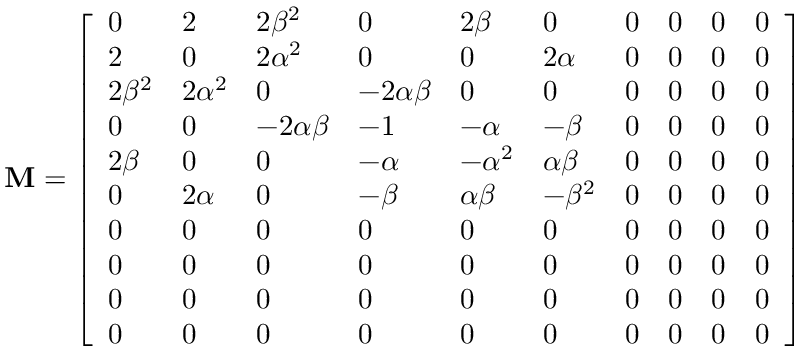<formula> <loc_0><loc_0><loc_500><loc_500>M = \left [ \begin{array} { l l l l l l l l l l } { 0 } & { 2 } & { 2 \beta ^ { 2 } } & { 0 } & { 2 \beta } & { 0 } & { 0 } & { 0 } & { 0 } & { 0 } \\ { 2 } & { 0 } & { 2 \alpha ^ { 2 } } & { 0 } & { 0 } & { 2 \alpha } & { 0 } & { 0 } & { 0 } & { 0 } \\ { 2 \beta ^ { 2 } } & { 2 \alpha ^ { 2 } } & { 0 } & { - 2 \alpha \beta } & { 0 } & { 0 } & { 0 } & { 0 } & { 0 } & { 0 } \\ { 0 } & { 0 } & { - 2 \alpha \beta } & { - 1 } & { - \alpha } & { - \beta } & { 0 } & { 0 } & { 0 } & { 0 } \\ { 2 \beta } & { 0 } & { 0 } & { - \alpha } & { - \alpha ^ { 2 } } & { \alpha \beta } & { 0 } & { 0 } & { 0 } & { 0 } \\ { 0 } & { 2 \alpha } & { 0 } & { - \beta } & { \alpha \beta } & { - \beta ^ { 2 } } & { 0 } & { 0 } & { 0 } & { 0 } \\ { 0 } & { 0 } & { 0 } & { 0 } & { 0 } & { 0 } & { 0 } & { 0 } & { 0 } & { 0 } \\ { 0 } & { 0 } & { 0 } & { 0 } & { 0 } & { 0 } & { 0 } & { 0 } & { 0 } & { 0 } \\ { 0 } & { 0 } & { 0 } & { 0 } & { 0 } & { 0 } & { 0 } & { 0 } & { 0 } & { 0 } \\ { 0 } & { 0 } & { 0 } & { 0 } & { 0 } & { 0 } & { 0 } & { 0 } & { 0 } & { 0 } \end{array} \right ]</formula> 